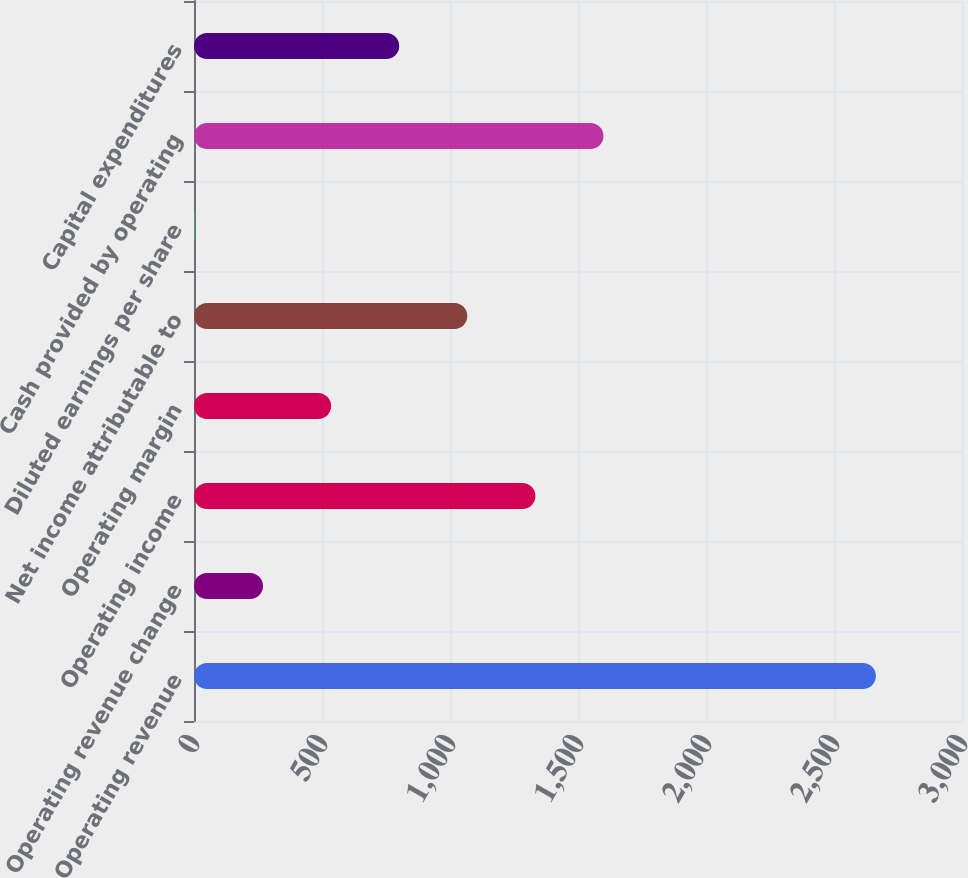<chart> <loc_0><loc_0><loc_500><loc_500><bar_chart><fcel>Operating revenue<fcel>Operating revenue change<fcel>Operating income<fcel>Operating margin<fcel>Net income attributable to<fcel>Diluted earnings per share<fcel>Cash provided by operating<fcel>Capital expenditures<nl><fcel>2663.6<fcel>269.56<fcel>1333.59<fcel>535.57<fcel>1067.59<fcel>3.55<fcel>1599.59<fcel>801.58<nl></chart> 